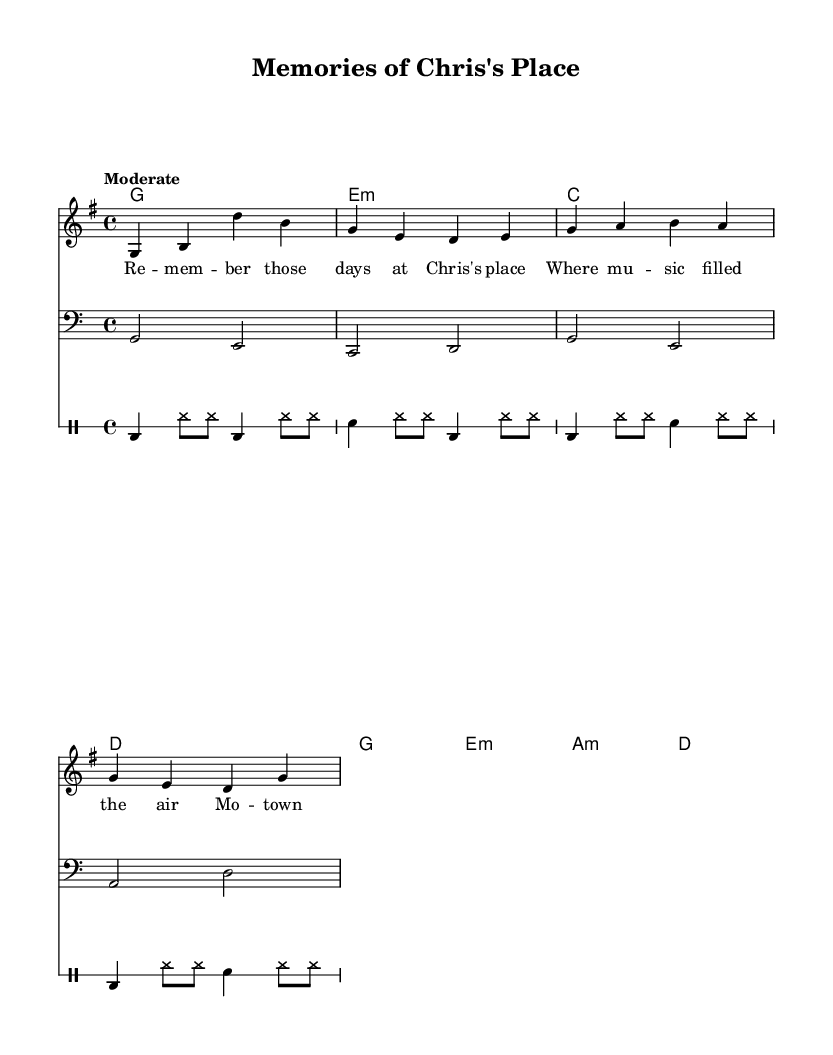What is the key signature of this music? The key signature is G major, which has one sharp (F#).
Answer: G major What is the time signature of the piece? The time signature shown is 4/4, meaning there are four beats in each measure.
Answer: 4/4 What is the tempo marking for this piece? The tempo marking indicates that the piece is to be played at a "Moderate" pace, suggesting a comfortable and steady speed.
Answer: Moderate What is the chord progression used in the first section? The initial chord progression includes G major, E minor, C major, and D major, which are common in rhythm and blues music.
Answer: G, E minor, C, D How many measures are there in the melody? The melody has a total of four measures, as indicated by the separation of notes into distinct groups.
Answer: 4 What type of drums are used in this score? The drum part includes bass drum (bd), snare drum (sn), and hi-hat (hh), which are typical in rhythm and blues drum patterns.
Answer: Bass drum, snare drum, hi-hat How is friendship conceptually tied to the lyrics of this piece? The lyrics reflect nostalgia for times spent with friends at Chris's place, underscoring the importance of music and companionship in creating memories.
Answer: Nostalgia and friendship 